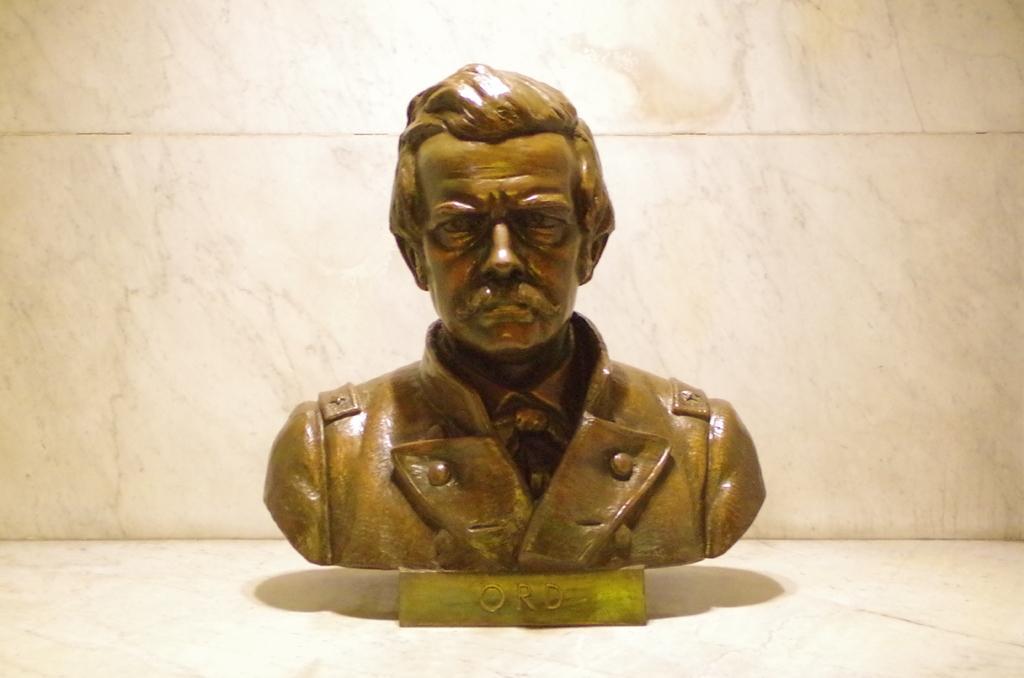How would you summarize this image in a sentence or two? In this image I can see the person statue in brown color. Background is in white color. 